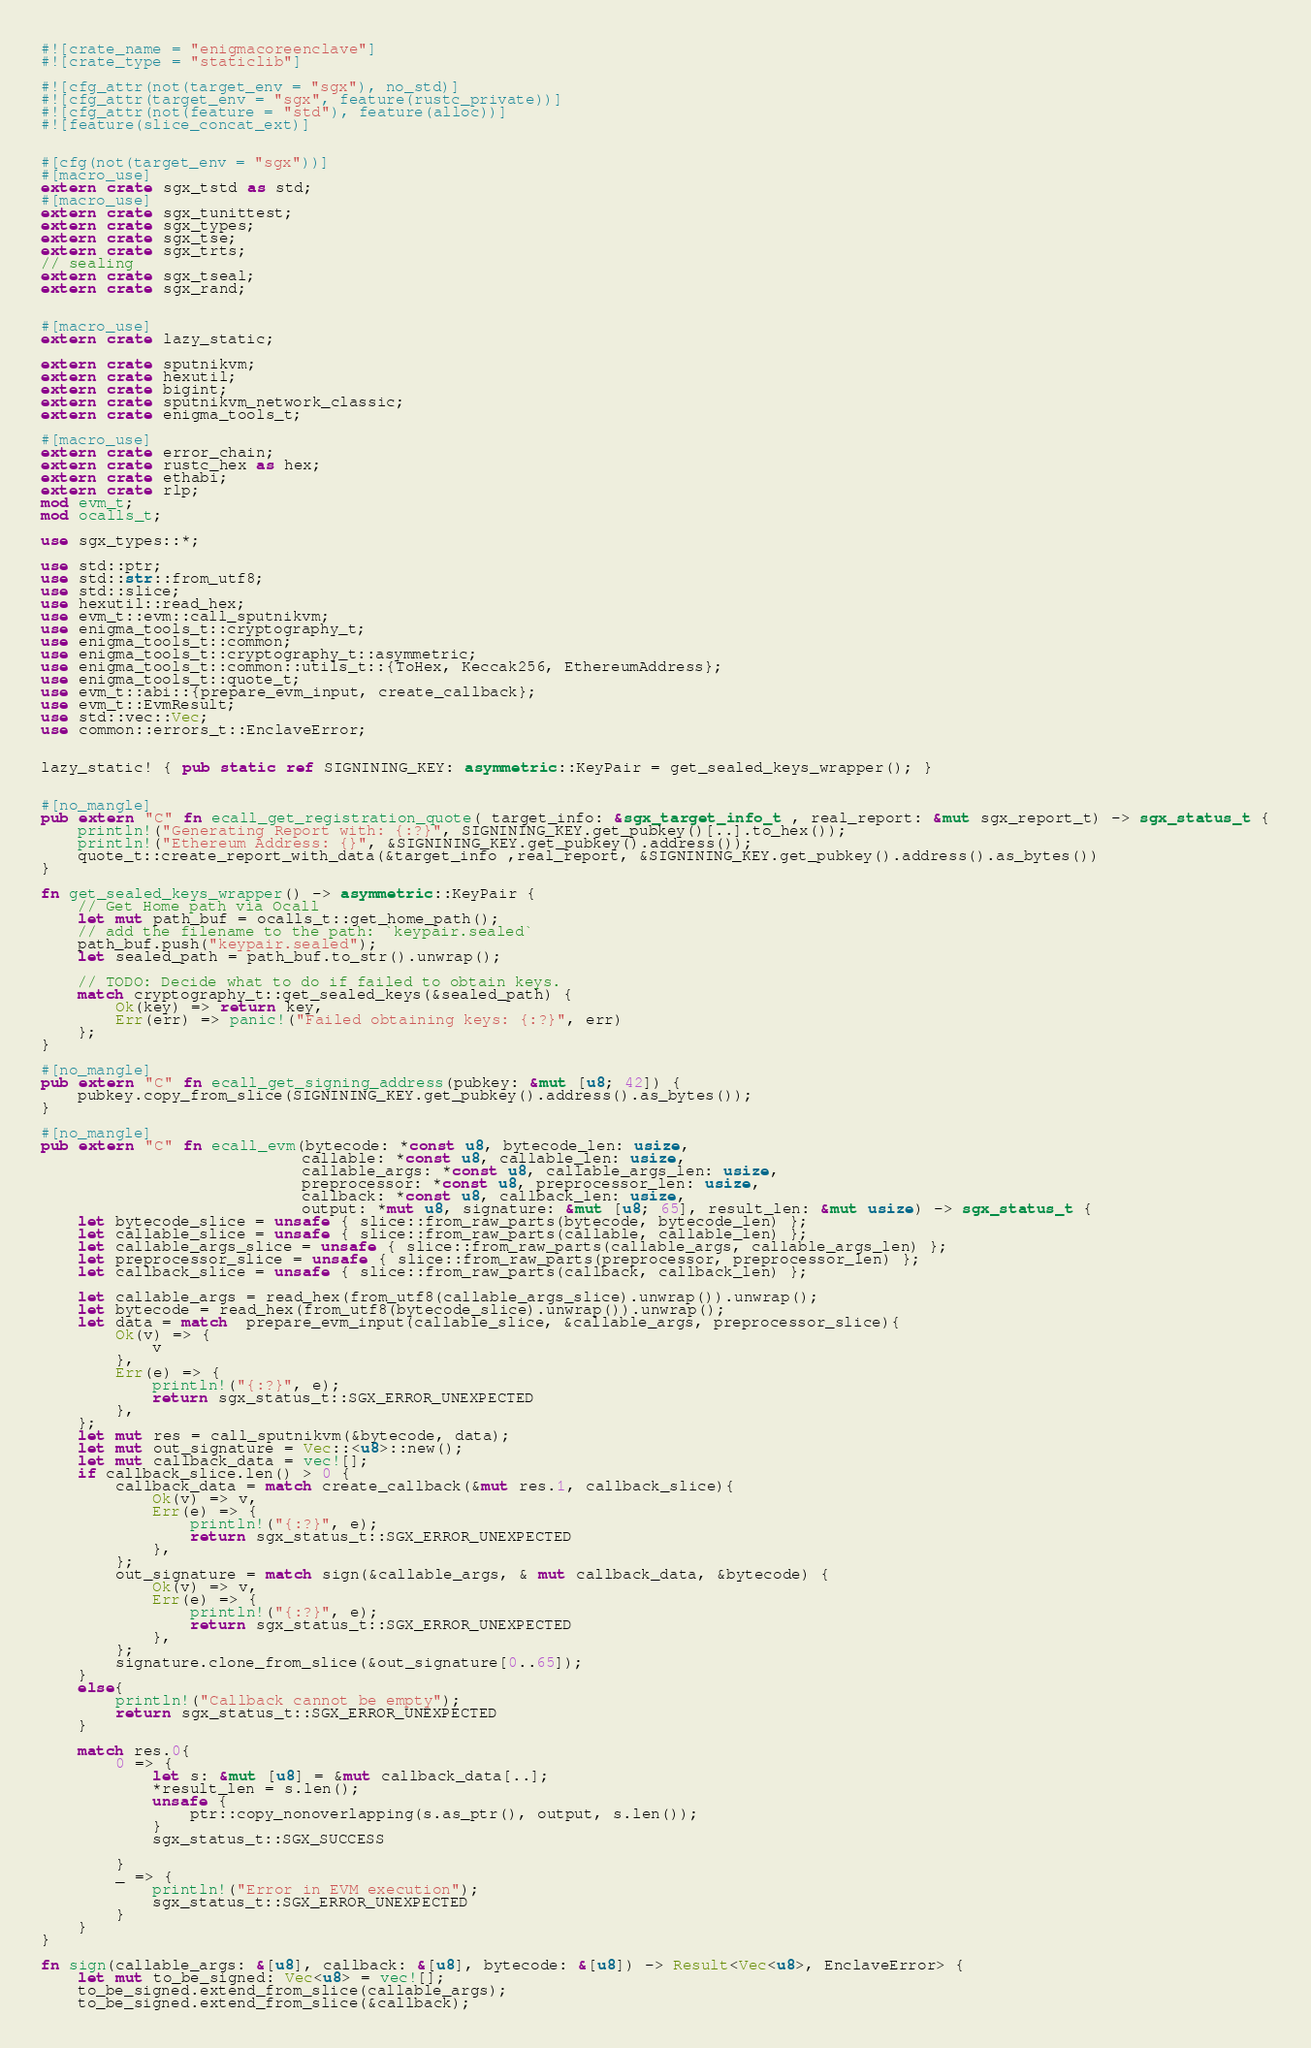Convert code to text. <code><loc_0><loc_0><loc_500><loc_500><_Rust_>
#![crate_name = "enigmacoreenclave"]
#![crate_type = "staticlib"]

#![cfg_attr(not(target_env = "sgx"), no_std)]
#![cfg_attr(target_env = "sgx", feature(rustc_private))]
#![cfg_attr(not(feature = "std"), feature(alloc))]
#![feature(slice_concat_ext)]


#[cfg(not(target_env = "sgx"))]
#[macro_use]
extern crate sgx_tstd as std;
#[macro_use]
extern crate sgx_tunittest;
extern crate sgx_types;
extern crate sgx_tse;
extern crate sgx_trts;
// sealing
extern crate sgx_tseal;
extern crate sgx_rand;


#[macro_use]
extern crate lazy_static;

extern crate sputnikvm;
extern crate hexutil;
extern crate bigint;
extern crate sputnikvm_network_classic;
extern crate enigma_tools_t;

#[macro_use]
extern crate error_chain;
extern crate rustc_hex as hex;
extern crate ethabi;
extern crate rlp;
mod evm_t;
mod ocalls_t;

use sgx_types::*;

use std::ptr;
use std::str::from_utf8;
use std::slice;
use hexutil::read_hex;
use evm_t::evm::call_sputnikvm;
use enigma_tools_t::cryptography_t;
use enigma_tools_t::common;
use enigma_tools_t::cryptography_t::asymmetric;
use enigma_tools_t::common::utils_t::{ToHex, Keccak256, EthereumAddress};
use enigma_tools_t::quote_t;
use evm_t::abi::{prepare_evm_input, create_callback};
use evm_t::EvmResult;
use std::vec::Vec;
use common::errors_t::EnclaveError;


lazy_static! { pub static ref SIGNINING_KEY: asymmetric::KeyPair = get_sealed_keys_wrapper(); }


#[no_mangle]
pub extern "C" fn ecall_get_registration_quote( target_info: &sgx_target_info_t , real_report: &mut sgx_report_t) -> sgx_status_t {
    println!("Generating Report with: {:?}", SIGNINING_KEY.get_pubkey()[..].to_hex());
    println!("Ethereum Address: {}", &SIGNINING_KEY.get_pubkey().address());
    quote_t::create_report_with_data(&target_info ,real_report, &SIGNINING_KEY.get_pubkey().address().as_bytes())
}

fn get_sealed_keys_wrapper() -> asymmetric::KeyPair {
    // Get Home path via Ocall
    let mut path_buf = ocalls_t::get_home_path();
    // add the filename to the path: `keypair.sealed`
    path_buf.push("keypair.sealed");
    let sealed_path = path_buf.to_str().unwrap();

    // TODO: Decide what to do if failed to obtain keys.
    match cryptography_t::get_sealed_keys(&sealed_path) {
        Ok(key) => return key,
        Err(err) => panic!("Failed obtaining keys: {:?}", err)
    };
}

#[no_mangle]
pub extern "C" fn ecall_get_signing_address(pubkey: &mut [u8; 42]) {
    pubkey.copy_from_slice(SIGNINING_KEY.get_pubkey().address().as_bytes());
}

#[no_mangle]
pub extern "C" fn ecall_evm(bytecode: *const u8, bytecode_len: usize,
                            callable: *const u8, callable_len: usize,
                            callable_args: *const u8, callable_args_len: usize,
                            preprocessor: *const u8, preprocessor_len: usize,
                            callback: *const u8, callback_len: usize,
                            output: *mut u8, signature: &mut [u8; 65], result_len: &mut usize) -> sgx_status_t {
    let bytecode_slice = unsafe { slice::from_raw_parts(bytecode, bytecode_len) };
    let callable_slice = unsafe { slice::from_raw_parts(callable, callable_len) };
    let callable_args_slice = unsafe { slice::from_raw_parts(callable_args, callable_args_len) };
    let preprocessor_slice = unsafe { slice::from_raw_parts(preprocessor, preprocessor_len) };
    let callback_slice = unsafe { slice::from_raw_parts(callback, callback_len) };

    let callable_args = read_hex(from_utf8(callable_args_slice).unwrap()).unwrap();
    let bytecode = read_hex(from_utf8(bytecode_slice).unwrap()).unwrap();
    let data = match  prepare_evm_input(callable_slice, &callable_args, preprocessor_slice){
        Ok(v) => {
            v
        },
        Err(e) => {
            println!("{:?}", e);
            return sgx_status_t::SGX_ERROR_UNEXPECTED
        },
    };
    let mut res = call_sputnikvm(&bytecode, data);
    let mut out_signature = Vec::<u8>::new();
    let mut callback_data = vec![];
    if callback_slice.len() > 0 {
        callback_data = match create_callback(&mut res.1, callback_slice){
            Ok(v) => v,
            Err(e) => {
                println!("{:?}", e);
                return sgx_status_t::SGX_ERROR_UNEXPECTED
            },
        };
        out_signature = match sign(&callable_args, & mut callback_data, &bytecode) {
            Ok(v) => v,
            Err(e) => {
                println!("{:?}", e);
                return sgx_status_t::SGX_ERROR_UNEXPECTED
            },
        };
        signature.clone_from_slice(&out_signature[0..65]);
    }
    else{
        println!("Callback cannot be empty");
        return sgx_status_t::SGX_ERROR_UNEXPECTED
    }

    match res.0{
        0 => {
            let s: &mut [u8] = &mut callback_data[..];
            *result_len = s.len();
            unsafe {
                ptr::copy_nonoverlapping(s.as_ptr(), output, s.len());
            }
            sgx_status_t::SGX_SUCCESS

        }
        _ => {
            println!("Error in EVM execution");
            sgx_status_t::SGX_ERROR_UNEXPECTED
        }
    }
}

fn sign(callable_args: &[u8], callback: &[u8], bytecode: &[u8]) -> Result<Vec<u8>, EnclaveError> {
    let mut to_be_signed: Vec<u8> = vec![];
    to_be_signed.extend_from_slice(callable_args);
    to_be_signed.extend_from_slice(&callback);</code> 